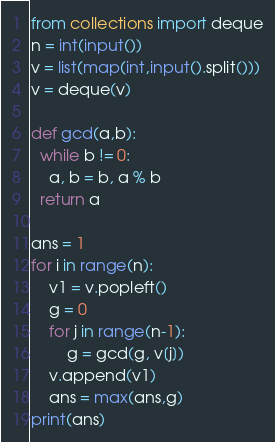<code> <loc_0><loc_0><loc_500><loc_500><_Python_>from collections import deque
n = int(input())
v = list(map(int,input().split()))
v = deque(v)

def gcd(a,b):
  while b != 0:
    a, b = b, a % b
  return a

ans = 1
for i in range(n):
    v1 = v.popleft()
    g = 0
    for j in range(n-1):
        g = gcd(g, v[j])
    v.append(v1)
    ans = max(ans,g)
print(ans)
</code> 